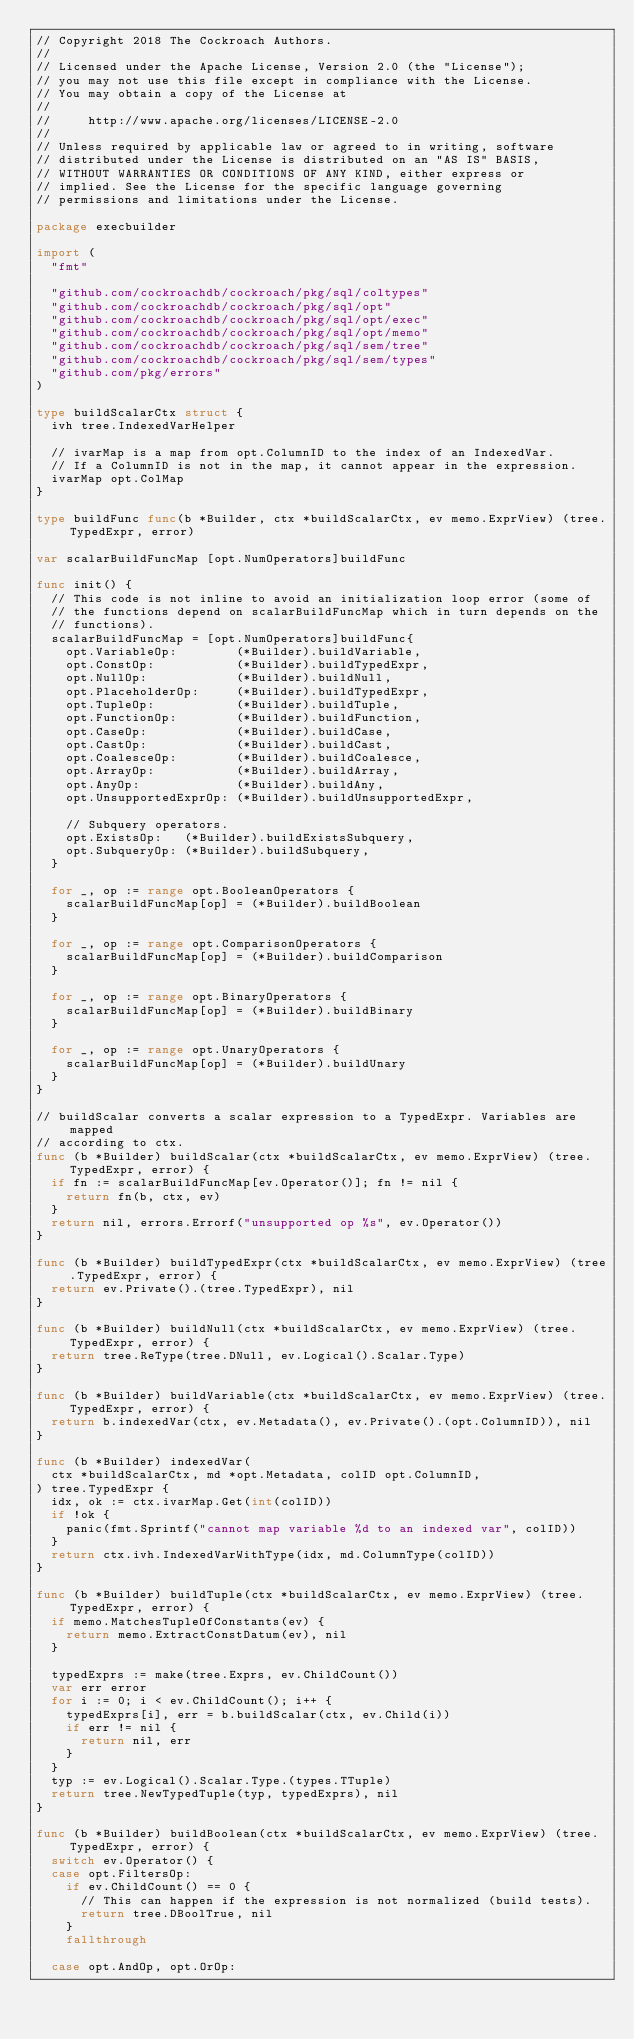Convert code to text. <code><loc_0><loc_0><loc_500><loc_500><_Go_>// Copyright 2018 The Cockroach Authors.
//
// Licensed under the Apache License, Version 2.0 (the "License");
// you may not use this file except in compliance with the License.
// You may obtain a copy of the License at
//
//     http://www.apache.org/licenses/LICENSE-2.0
//
// Unless required by applicable law or agreed to in writing, software
// distributed under the License is distributed on an "AS IS" BASIS,
// WITHOUT WARRANTIES OR CONDITIONS OF ANY KIND, either express or
// implied. See the License for the specific language governing
// permissions and limitations under the License.

package execbuilder

import (
	"fmt"

	"github.com/cockroachdb/cockroach/pkg/sql/coltypes"
	"github.com/cockroachdb/cockroach/pkg/sql/opt"
	"github.com/cockroachdb/cockroach/pkg/sql/opt/exec"
	"github.com/cockroachdb/cockroach/pkg/sql/opt/memo"
	"github.com/cockroachdb/cockroach/pkg/sql/sem/tree"
	"github.com/cockroachdb/cockroach/pkg/sql/sem/types"
	"github.com/pkg/errors"
)

type buildScalarCtx struct {
	ivh tree.IndexedVarHelper

	// ivarMap is a map from opt.ColumnID to the index of an IndexedVar.
	// If a ColumnID is not in the map, it cannot appear in the expression.
	ivarMap opt.ColMap
}

type buildFunc func(b *Builder, ctx *buildScalarCtx, ev memo.ExprView) (tree.TypedExpr, error)

var scalarBuildFuncMap [opt.NumOperators]buildFunc

func init() {
	// This code is not inline to avoid an initialization loop error (some of
	// the functions depend on scalarBuildFuncMap which in turn depends on the
	// functions).
	scalarBuildFuncMap = [opt.NumOperators]buildFunc{
		opt.VariableOp:        (*Builder).buildVariable,
		opt.ConstOp:           (*Builder).buildTypedExpr,
		opt.NullOp:            (*Builder).buildNull,
		opt.PlaceholderOp:     (*Builder).buildTypedExpr,
		opt.TupleOp:           (*Builder).buildTuple,
		opt.FunctionOp:        (*Builder).buildFunction,
		opt.CaseOp:            (*Builder).buildCase,
		opt.CastOp:            (*Builder).buildCast,
		opt.CoalesceOp:        (*Builder).buildCoalesce,
		opt.ArrayOp:           (*Builder).buildArray,
		opt.AnyOp:             (*Builder).buildAny,
		opt.UnsupportedExprOp: (*Builder).buildUnsupportedExpr,

		// Subquery operators.
		opt.ExistsOp:   (*Builder).buildExistsSubquery,
		opt.SubqueryOp: (*Builder).buildSubquery,
	}

	for _, op := range opt.BooleanOperators {
		scalarBuildFuncMap[op] = (*Builder).buildBoolean
	}

	for _, op := range opt.ComparisonOperators {
		scalarBuildFuncMap[op] = (*Builder).buildComparison
	}

	for _, op := range opt.BinaryOperators {
		scalarBuildFuncMap[op] = (*Builder).buildBinary
	}

	for _, op := range opt.UnaryOperators {
		scalarBuildFuncMap[op] = (*Builder).buildUnary
	}
}

// buildScalar converts a scalar expression to a TypedExpr. Variables are mapped
// according to ctx.
func (b *Builder) buildScalar(ctx *buildScalarCtx, ev memo.ExprView) (tree.TypedExpr, error) {
	if fn := scalarBuildFuncMap[ev.Operator()]; fn != nil {
		return fn(b, ctx, ev)
	}
	return nil, errors.Errorf("unsupported op %s", ev.Operator())
}

func (b *Builder) buildTypedExpr(ctx *buildScalarCtx, ev memo.ExprView) (tree.TypedExpr, error) {
	return ev.Private().(tree.TypedExpr), nil
}

func (b *Builder) buildNull(ctx *buildScalarCtx, ev memo.ExprView) (tree.TypedExpr, error) {
	return tree.ReType(tree.DNull, ev.Logical().Scalar.Type)
}

func (b *Builder) buildVariable(ctx *buildScalarCtx, ev memo.ExprView) (tree.TypedExpr, error) {
	return b.indexedVar(ctx, ev.Metadata(), ev.Private().(opt.ColumnID)), nil
}

func (b *Builder) indexedVar(
	ctx *buildScalarCtx, md *opt.Metadata, colID opt.ColumnID,
) tree.TypedExpr {
	idx, ok := ctx.ivarMap.Get(int(colID))
	if !ok {
		panic(fmt.Sprintf("cannot map variable %d to an indexed var", colID))
	}
	return ctx.ivh.IndexedVarWithType(idx, md.ColumnType(colID))
}

func (b *Builder) buildTuple(ctx *buildScalarCtx, ev memo.ExprView) (tree.TypedExpr, error) {
	if memo.MatchesTupleOfConstants(ev) {
		return memo.ExtractConstDatum(ev), nil
	}

	typedExprs := make(tree.Exprs, ev.ChildCount())
	var err error
	for i := 0; i < ev.ChildCount(); i++ {
		typedExprs[i], err = b.buildScalar(ctx, ev.Child(i))
		if err != nil {
			return nil, err
		}
	}
	typ := ev.Logical().Scalar.Type.(types.TTuple)
	return tree.NewTypedTuple(typ, typedExprs), nil
}

func (b *Builder) buildBoolean(ctx *buildScalarCtx, ev memo.ExprView) (tree.TypedExpr, error) {
	switch ev.Operator() {
	case opt.FiltersOp:
		if ev.ChildCount() == 0 {
			// This can happen if the expression is not normalized (build tests).
			return tree.DBoolTrue, nil
		}
		fallthrough

	case opt.AndOp, opt.OrOp:</code> 